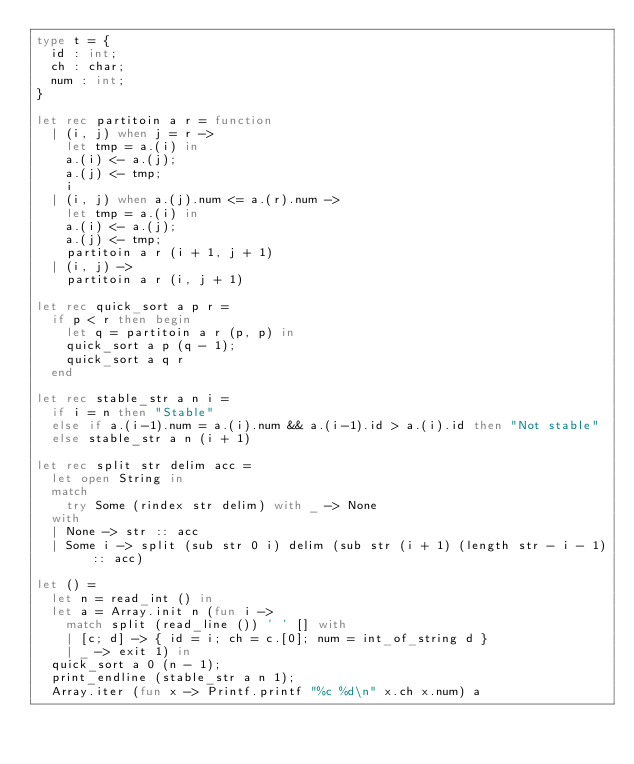<code> <loc_0><loc_0><loc_500><loc_500><_OCaml_>type t = {
  id : int;
  ch : char;
  num : int;
}

let rec partitoin a r = function
  | (i, j) when j = r ->
    let tmp = a.(i) in
    a.(i) <- a.(j);
    a.(j) <- tmp;
    i
  | (i, j) when a.(j).num <= a.(r).num ->
    let tmp = a.(i) in
    a.(i) <- a.(j);
    a.(j) <- tmp;
    partitoin a r (i + 1, j + 1)
  | (i, j) ->
    partitoin a r (i, j + 1)

let rec quick_sort a p r =
  if p < r then begin
    let q = partitoin a r (p, p) in
    quick_sort a p (q - 1);
    quick_sort a q r
  end

let rec stable_str a n i =
  if i = n then "Stable"
  else if a.(i-1).num = a.(i).num && a.(i-1).id > a.(i).id then "Not stable"
  else stable_str a n (i + 1)

let rec split str delim acc =
  let open String in
  match
    try Some (rindex str delim) with _ -> None
  with
  | None -> str :: acc
  | Some i -> split (sub str 0 i) delim (sub str (i + 1) (length str - i - 1) :: acc)

let () =
  let n = read_int () in
  let a = Array.init n (fun i ->
    match split (read_line ()) ' ' [] with
    | [c; d] -> { id = i; ch = c.[0]; num = int_of_string d }
    | _ -> exit 1) in
  quick_sort a 0 (n - 1);
  print_endline (stable_str a n 1);
  Array.iter (fun x -> Printf.printf "%c %d\n" x.ch x.num) a</code> 